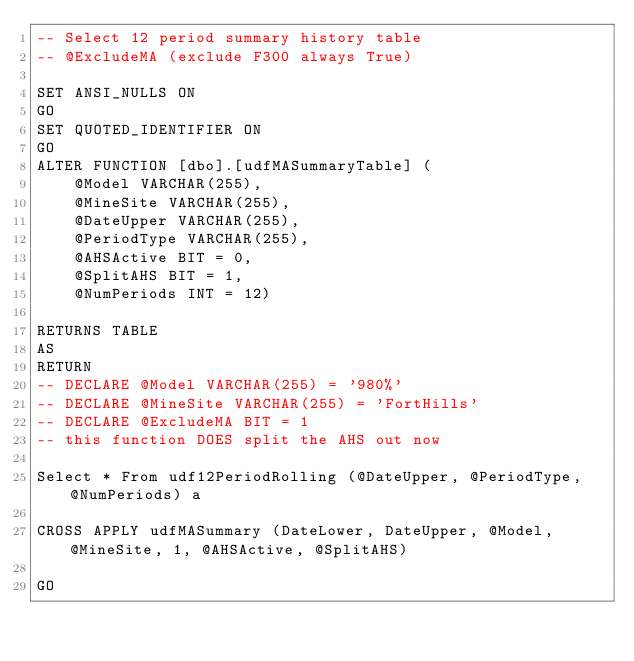<code> <loc_0><loc_0><loc_500><loc_500><_SQL_>-- Select 12 period summary history table
-- @ExcludeMA (exclude F300 always True)

SET ANSI_NULLS ON
GO
SET QUOTED_IDENTIFIER ON
GO
ALTER FUNCTION [dbo].[udfMASummaryTable] (
    @Model VARCHAR(255),
    @MineSite VARCHAR(255),
    @DateUpper VARCHAR(255),
    @PeriodType VARCHAR(255), 
    @AHSActive BIT = 0,
    @SplitAHS BIT = 1,
    @NumPeriods INT = 12)

RETURNS TABLE
AS
RETURN
-- DECLARE @Model VARCHAR(255) = '980%'
-- DECLARE @MineSite VARCHAR(255) = 'FortHills'
-- DECLARE @ExcludeMA BIT = 1
-- this function DOES split the AHS out now

Select * From udf12PeriodRolling (@DateUpper, @PeriodType, @NumPeriods) a

CROSS APPLY udfMASummary (DateLower, DateUpper, @Model, @MineSite, 1, @AHSActive, @SplitAHS)

GO
</code> 